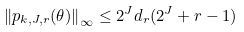Convert formula to latex. <formula><loc_0><loc_0><loc_500><loc_500>\left \| p _ { k , J , r } ( \theta ) \right \| _ { \infty } \leq 2 ^ { J } d _ { r } ( 2 ^ { J } + r - 1 )</formula> 